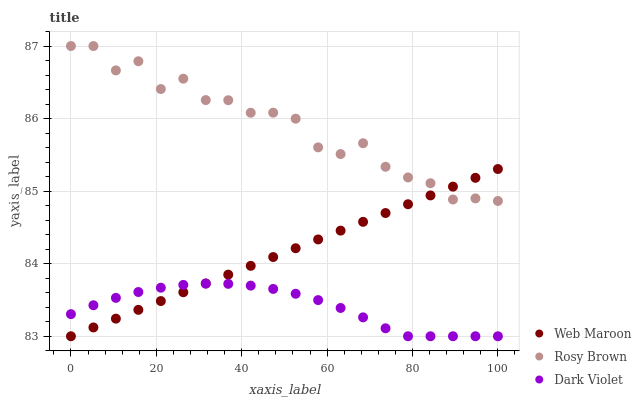Does Dark Violet have the minimum area under the curve?
Answer yes or no. Yes. Does Rosy Brown have the maximum area under the curve?
Answer yes or no. Yes. Does Web Maroon have the minimum area under the curve?
Answer yes or no. No. Does Web Maroon have the maximum area under the curve?
Answer yes or no. No. Is Web Maroon the smoothest?
Answer yes or no. Yes. Is Rosy Brown the roughest?
Answer yes or no. Yes. Is Dark Violet the smoothest?
Answer yes or no. No. Is Dark Violet the roughest?
Answer yes or no. No. Does Web Maroon have the lowest value?
Answer yes or no. Yes. Does Rosy Brown have the highest value?
Answer yes or no. Yes. Does Web Maroon have the highest value?
Answer yes or no. No. Is Dark Violet less than Rosy Brown?
Answer yes or no. Yes. Is Rosy Brown greater than Dark Violet?
Answer yes or no. Yes. Does Web Maroon intersect Dark Violet?
Answer yes or no. Yes. Is Web Maroon less than Dark Violet?
Answer yes or no. No. Is Web Maroon greater than Dark Violet?
Answer yes or no. No. Does Dark Violet intersect Rosy Brown?
Answer yes or no. No. 